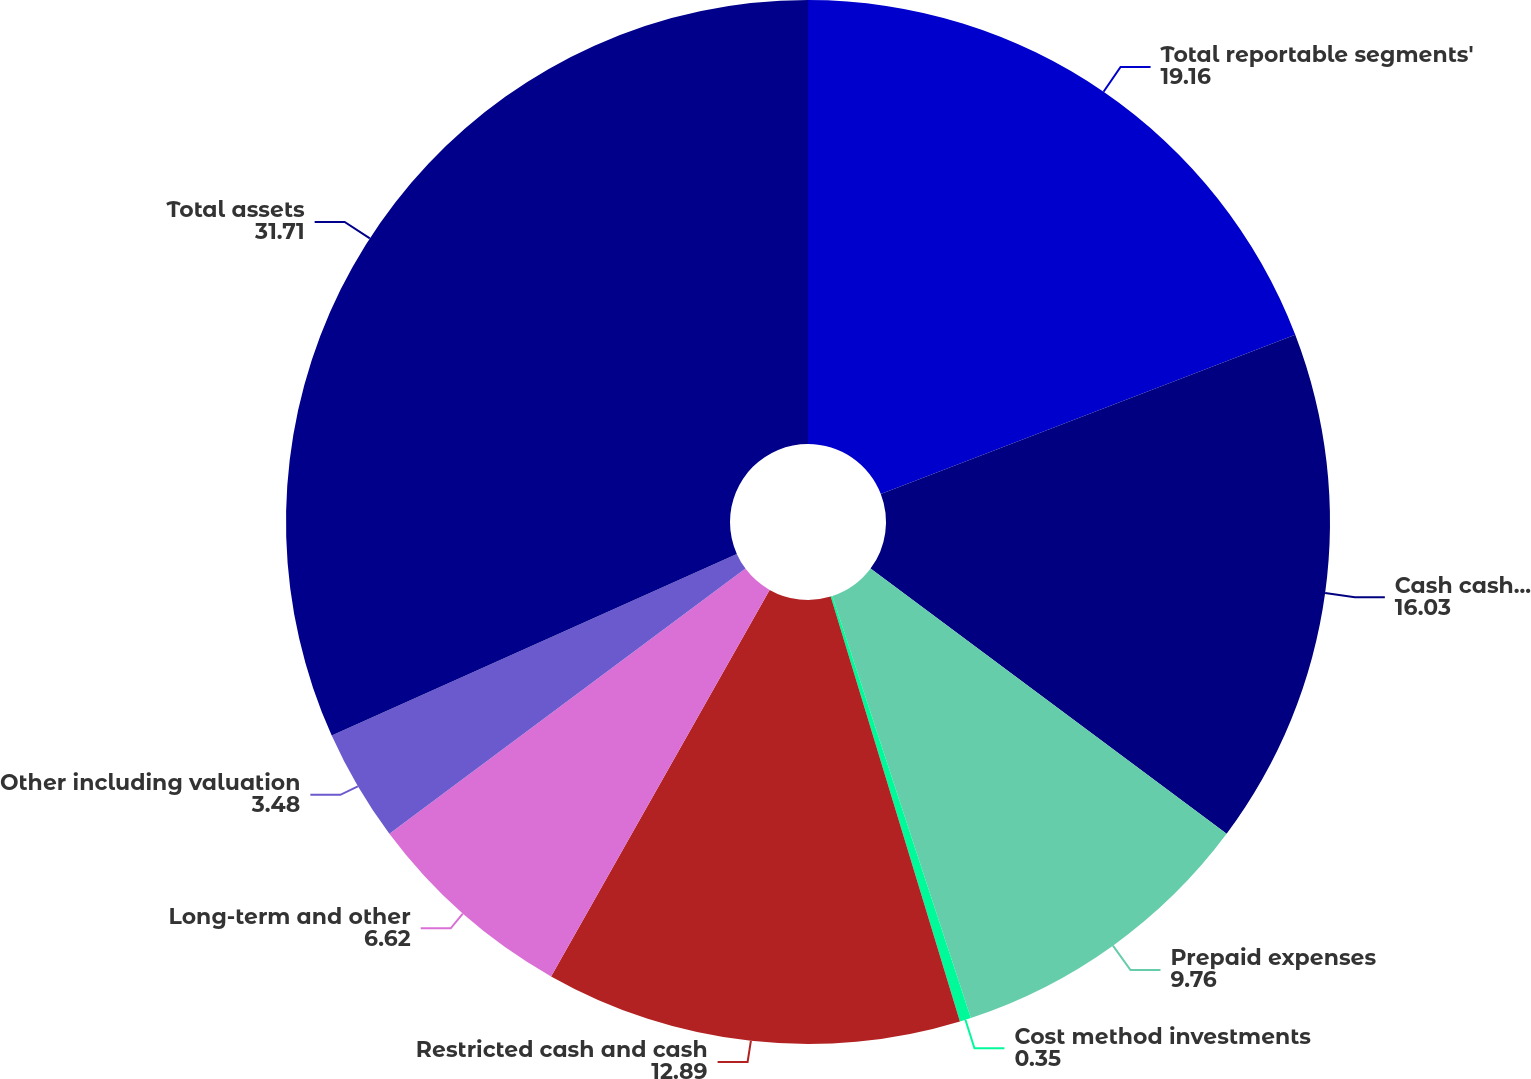<chart> <loc_0><loc_0><loc_500><loc_500><pie_chart><fcel>Total reportable segments'<fcel>Cash cash equivalents and<fcel>Prepaid expenses<fcel>Cost method investments<fcel>Restricted cash and cash<fcel>Long-term and other<fcel>Other including valuation<fcel>Total assets<nl><fcel>19.16%<fcel>16.03%<fcel>9.76%<fcel>0.35%<fcel>12.89%<fcel>6.62%<fcel>3.48%<fcel>31.71%<nl></chart> 